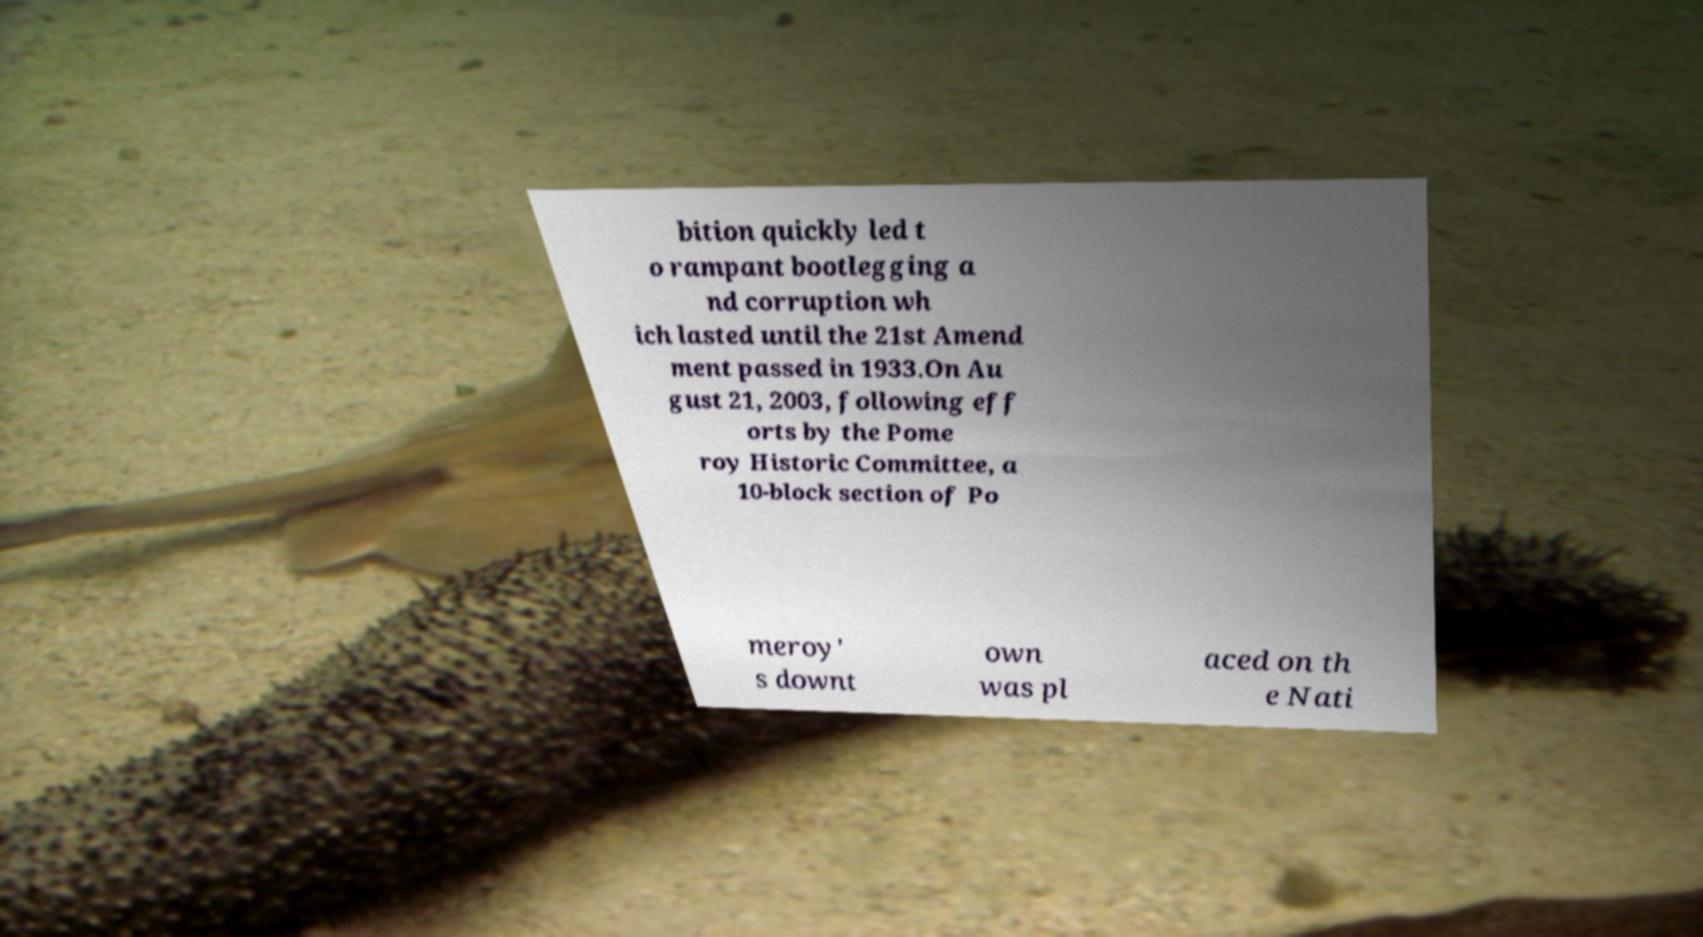Please read and relay the text visible in this image. What does it say? bition quickly led t o rampant bootlegging a nd corruption wh ich lasted until the 21st Amend ment passed in 1933.On Au gust 21, 2003, following eff orts by the Pome roy Historic Committee, a 10-block section of Po meroy' s downt own was pl aced on th e Nati 